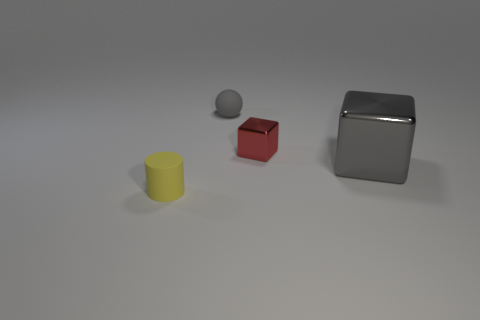How does the lighting in the image affect the appearance of the objects? The lighting in the image creates soft shadows and subtle highlights on the objects, enhancing their three-dimensional form. It also influences the color perception of each object, with the shiny surfaces reflecting more light and appearing brighter, while the matte surfaces absorb light and appear flatter. 